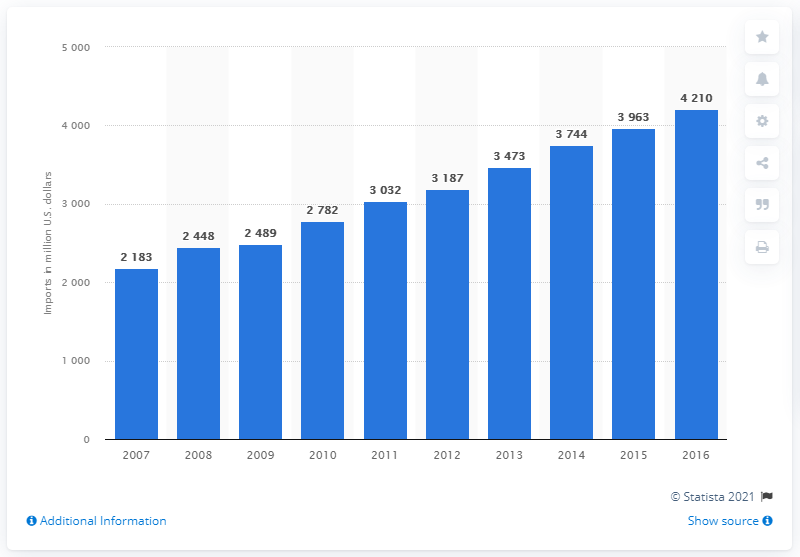Specify some key components in this picture. In 2016, the value is greater than 4000. The average of the highest and lowest values is 3196.5. 